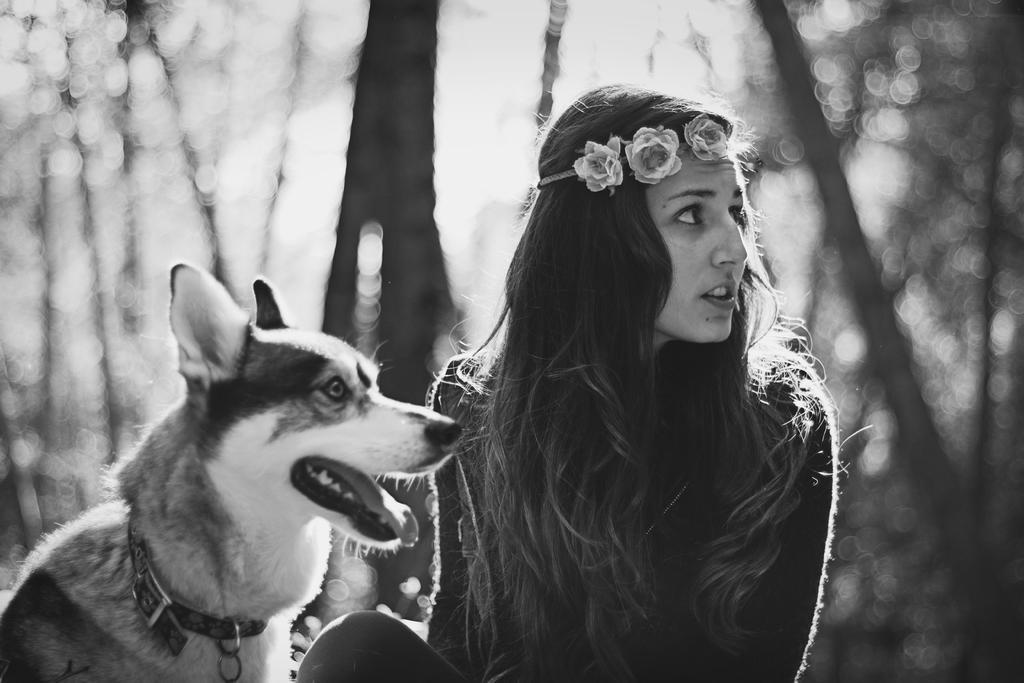In one or two sentences, can you explain what this image depicts? In this picture we can see a woman,dog and in the background we can see trees it is blurry. 